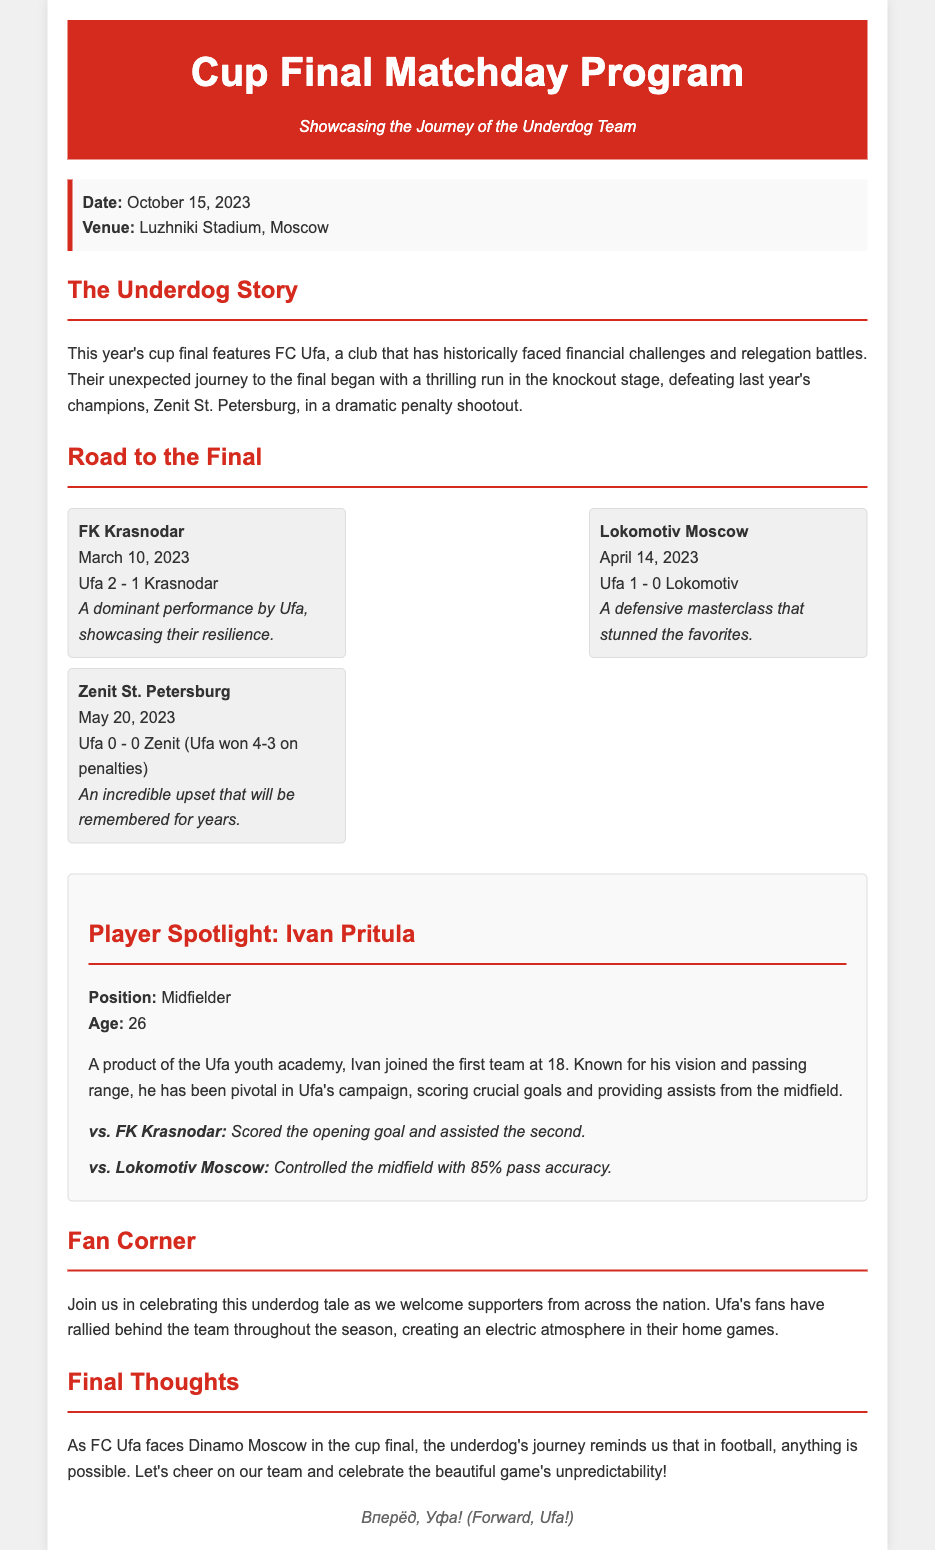What is the match date? The match date is specified in the document under match information.
Answer: October 15, 2023 Where is the cup final being held? The venue for the cup final is mentioned in the document.
Answer: Luzhniki Stadium, Moscow Which team is featured as the underdog? The document highlights a specific team as the underdog in the final.
Answer: FC Ufa Who did FC Ufa defeat in the semi-finals? The document lists the teams that Ufa played against in the knockout stage.
Answer: Zenit St. Petersburg What was the score in the match against Lokomotiv Moscow? The document provides the score of the match against Lokomotiv.
Answer: Ufa 1 - 0 Lokomotiv How old is Ivan Pritula? The player information section includes the player's age.
Answer: 26 What percentage of pass accuracy did Ivan have against Lokomotiv? The document specifies Ivan's pass accuracy in a notable match.
Answer: 85% What significant accomplishment did Ufa achieve against FK Krasnodar? The document notes Ufa's performance in the match, highlighting a specific achievement.
Answer: Dominant performance 